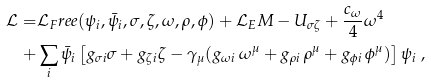<formula> <loc_0><loc_0><loc_500><loc_500>\mathcal { L } = & \mathcal { L } _ { F } r e e ( \psi _ { i } , \bar { \psi } _ { i } , \sigma , \zeta , \omega , \rho , \phi ) + \mathcal { L } _ { E } M - U _ { \sigma \zeta } + \frac { c _ { \omega } } { 4 } \omega ^ { 4 } \\ + & \sum _ { i } \bar { \psi } _ { i } \left [ g _ { \sigma i } \sigma + g _ { \zeta i } \zeta - \gamma _ { \mu } ( g _ { \omega i } \, { \omega } ^ { \mu } + g _ { \rho i } \, { \rho } ^ { \mu } + g _ { \phi i } \, { \phi } ^ { \mu } ) \right ] \psi _ { i } \ ,</formula> 